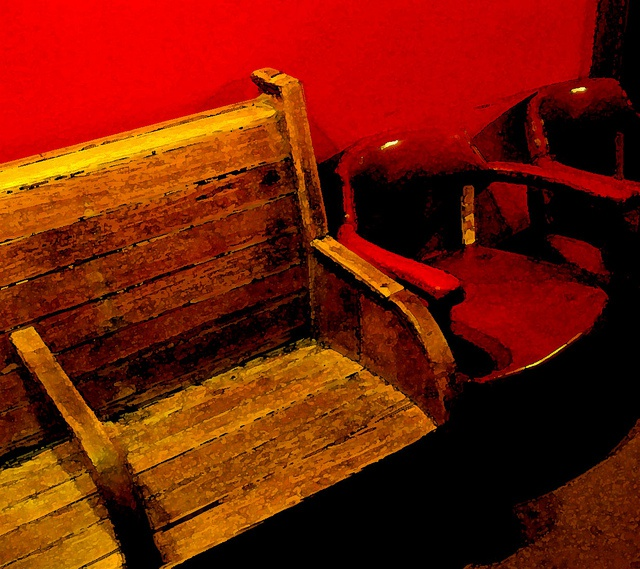Describe the objects in this image and their specific colors. I can see bench in red, maroon, brown, and black tones, chair in red, black, and maroon tones, and chair in red, black, maroon, and brown tones in this image. 